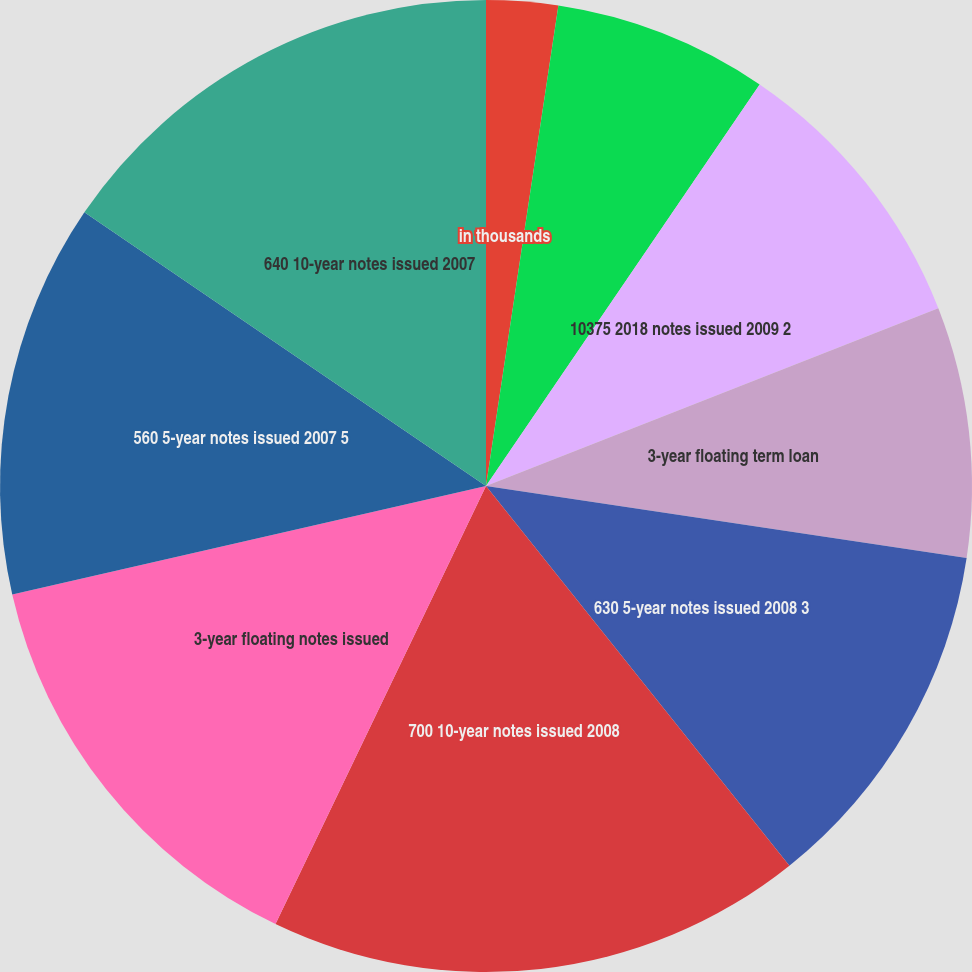Convert chart. <chart><loc_0><loc_0><loc_500><loc_500><pie_chart><fcel>in thousands<fcel>5-year floating term loan<fcel>10125 2015 notes issued 2009 1<fcel>10375 2018 notes issued 2009 2<fcel>3-year floating term loan<fcel>630 5-year notes issued 2008 3<fcel>700 10-year notes issued 2008<fcel>3-year floating notes issued<fcel>560 5-year notes issued 2007 5<fcel>640 10-year notes issued 2007<nl><fcel>2.38%<fcel>0.0%<fcel>7.14%<fcel>9.52%<fcel>8.33%<fcel>11.9%<fcel>17.86%<fcel>14.29%<fcel>13.1%<fcel>15.48%<nl></chart> 